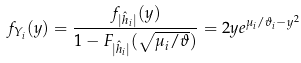<formula> <loc_0><loc_0><loc_500><loc_500>f _ { Y _ { i } } ( y ) & = \frac { f _ { | \hat { h } _ { i } | } ( y ) } { 1 - F _ { | \hat { h } _ { i } | } ( \sqrt { \mu _ { i } / \vartheta } ) } = 2 y e ^ { \mu _ { i } / \vartheta _ { i } - y ^ { 2 } }</formula> 